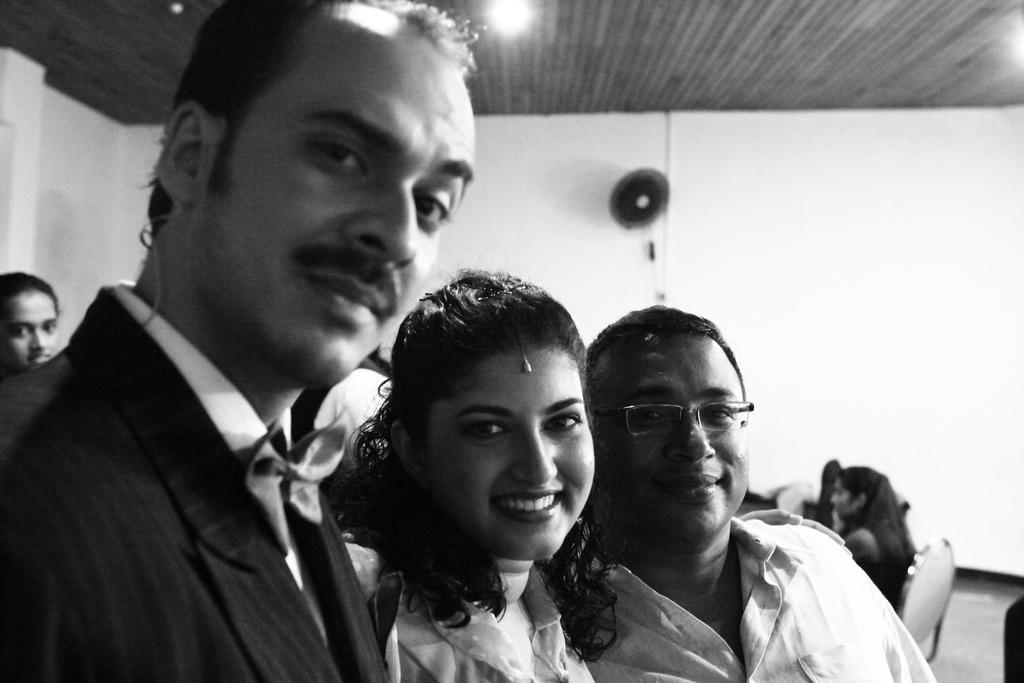Describe this image in one or two sentences. This is a black and white image. In front of the image there are three persons standing. There is a man with spectacles. Behind him there is a person sitting on a chair. And on the left side of the image behind the man there is a person. In the background, on the wall there is a fan. At the top of the image there is a ceiling with lights. 